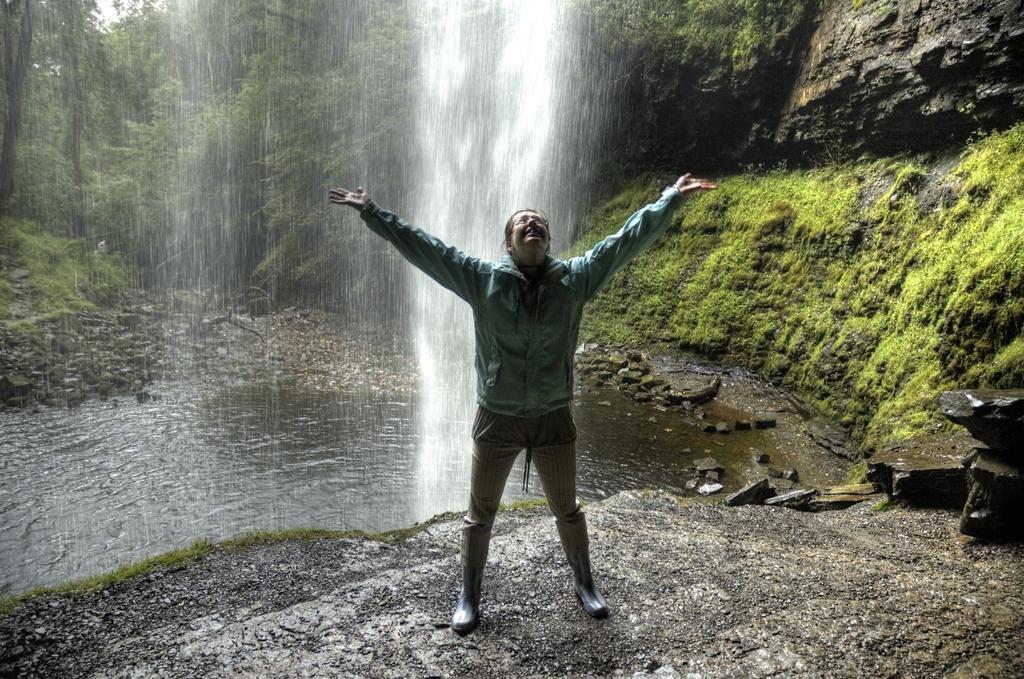Please provide a concise description of this image. In this picture I can see there is a person standing here and there is a water fall in the backdrop and I can see there is a pond here and there is a mountain in the backdrop. There are trees and plants. 